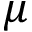<formula> <loc_0><loc_0><loc_500><loc_500>\mu</formula> 